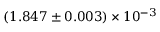Convert formula to latex. <formula><loc_0><loc_0><loc_500><loc_500>( 1 . 8 4 7 \pm 0 . 0 0 3 ) \times 1 0 ^ { - 3 }</formula> 